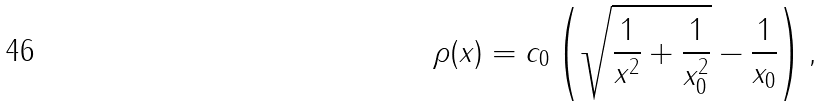Convert formula to latex. <formula><loc_0><loc_0><loc_500><loc_500>\rho ( x ) = c _ { 0 } \left ( \sqrt { \frac { 1 } { x ^ { 2 } } + \frac { 1 } { x _ { 0 } ^ { 2 } } } - \frac { 1 } { x _ { 0 } } \right ) ,</formula> 